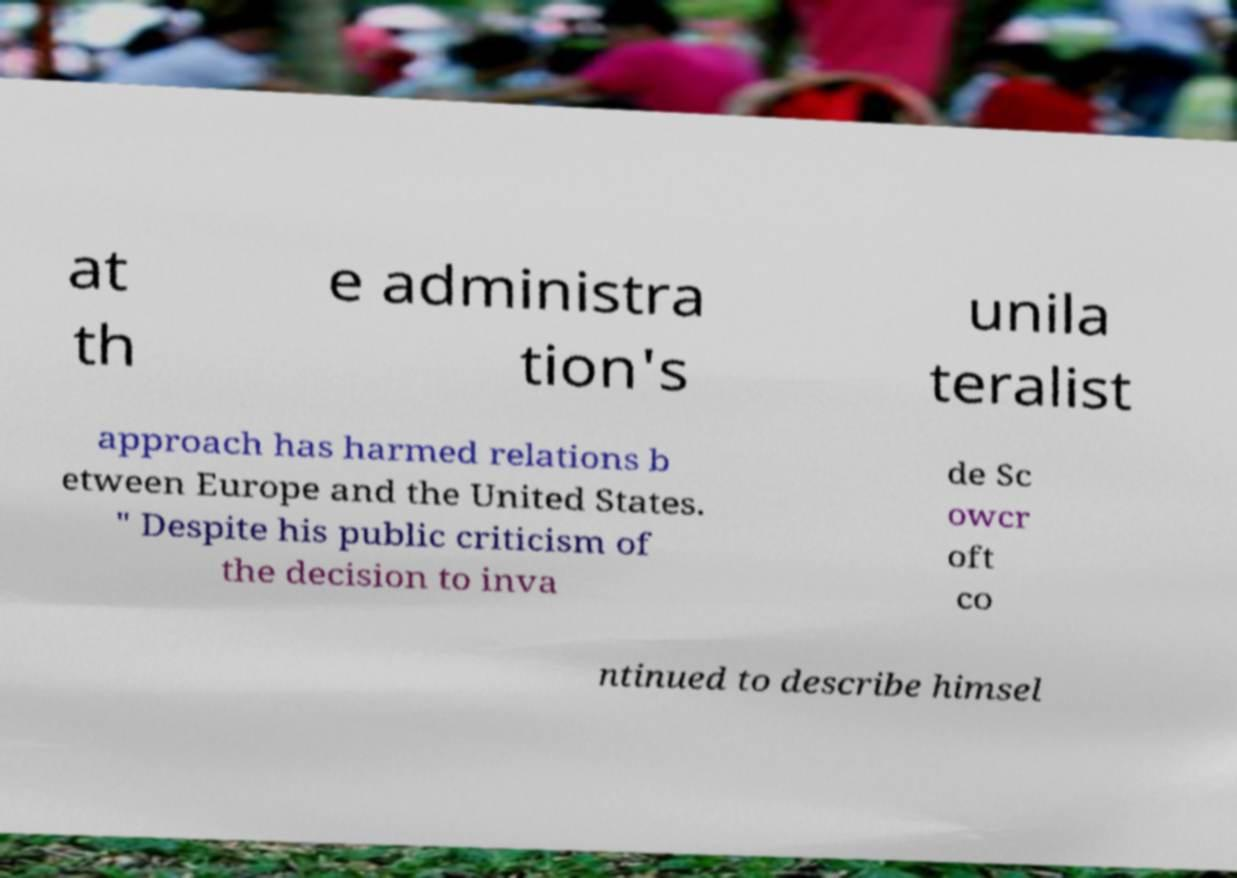Please read and relay the text visible in this image. What does it say? at th e administra tion's unila teralist approach has harmed relations b etween Europe and the United States. " Despite his public criticism of the decision to inva de Sc owcr oft co ntinued to describe himsel 